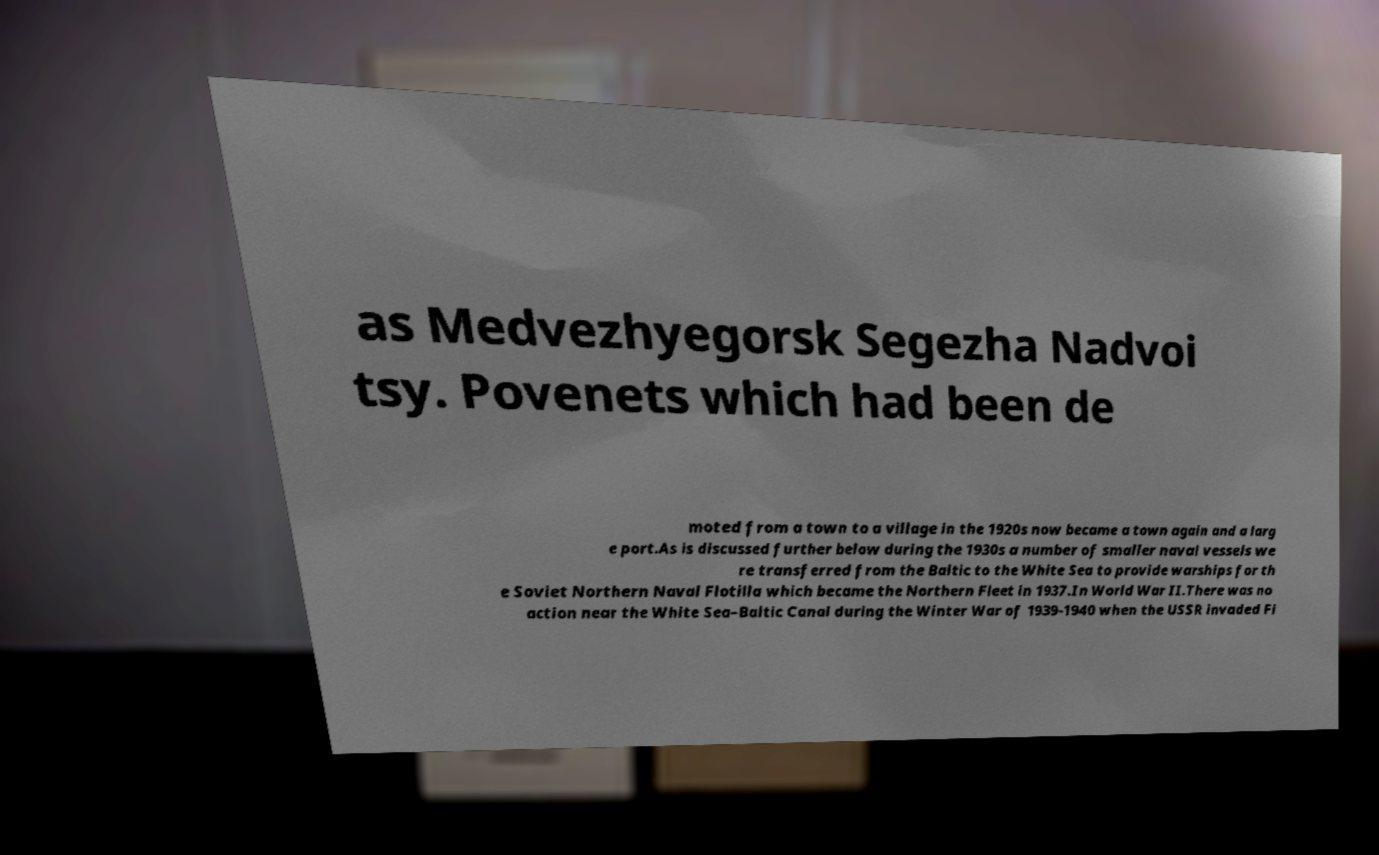Could you extract and type out the text from this image? as Medvezhyegorsk Segezha Nadvoi tsy. Povenets which had been de moted from a town to a village in the 1920s now became a town again and a larg e port.As is discussed further below during the 1930s a number of smaller naval vessels we re transferred from the Baltic to the White Sea to provide warships for th e Soviet Northern Naval Flotilla which became the Northern Fleet in 1937.In World War II.There was no action near the White Sea–Baltic Canal during the Winter War of 1939-1940 when the USSR invaded Fi 